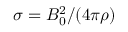<formula> <loc_0><loc_0><loc_500><loc_500>\sigma = B _ { 0 } ^ { 2 } / ( 4 \pi \rho )</formula> 